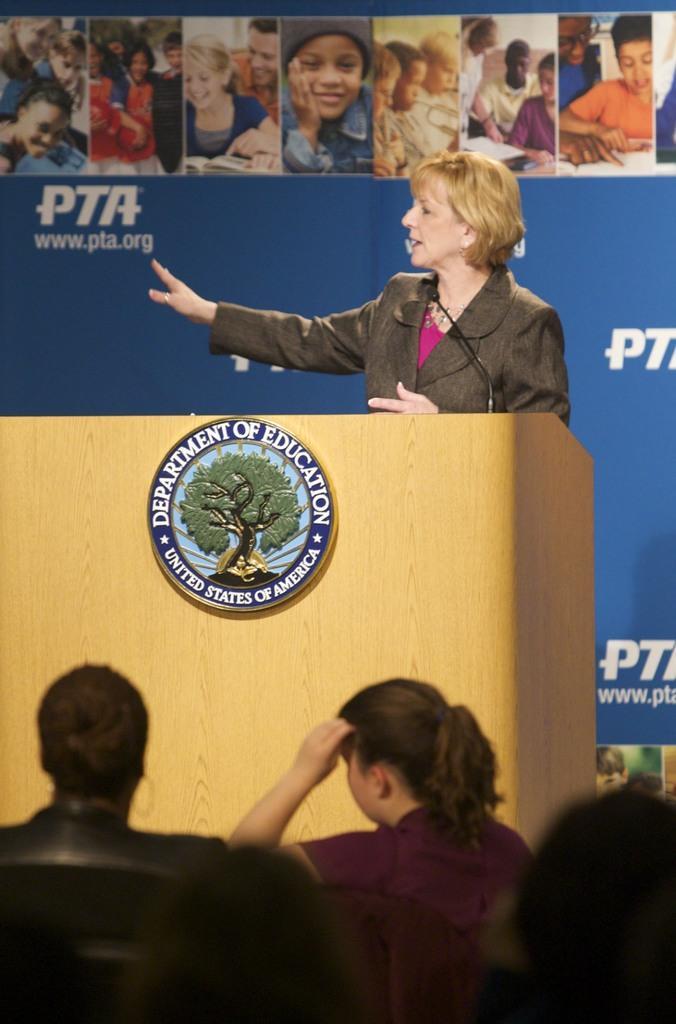In one or two sentences, can you explain what this image depicts? In this picture we can see some people are sitting on chairs and a woman is standing behind the podium and on the podium there is a badge and a microphone. Behind the people there is a board. 